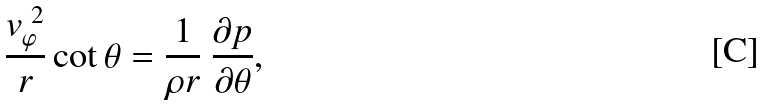<formula> <loc_0><loc_0><loc_500><loc_500>\frac { v _ { \varphi } ^ { \ 2 } } { r } \cot \theta = \frac { 1 } { \rho r } \ \frac { \partial p } { \partial \theta } ,</formula> 